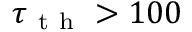<formula> <loc_0><loc_0><loc_500><loc_500>\tau _ { t h } > 1 0 0</formula> 